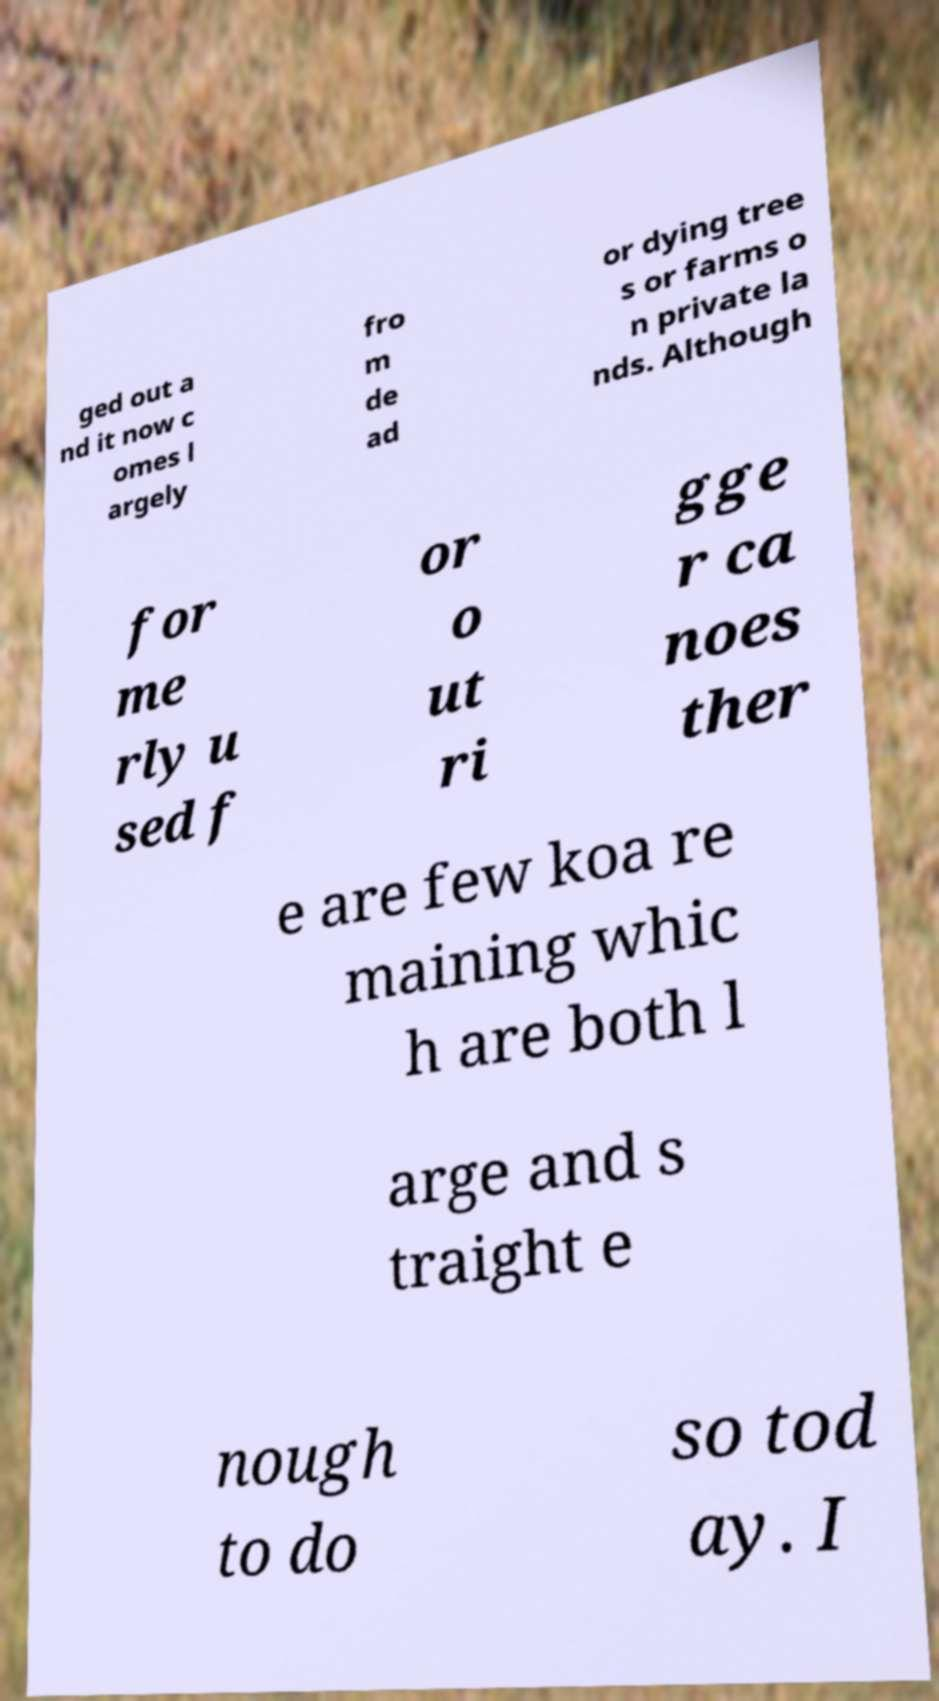For documentation purposes, I need the text within this image transcribed. Could you provide that? ged out a nd it now c omes l argely fro m de ad or dying tree s or farms o n private la nds. Although for me rly u sed f or o ut ri gge r ca noes ther e are few koa re maining whic h are both l arge and s traight e nough to do so tod ay. I 